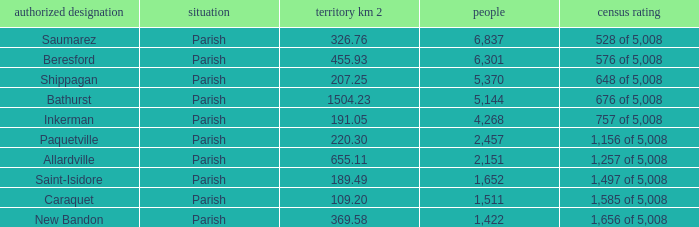What is the Population of the New Bandon Parish with an Area km 2 larger than 326.76? 1422.0. 